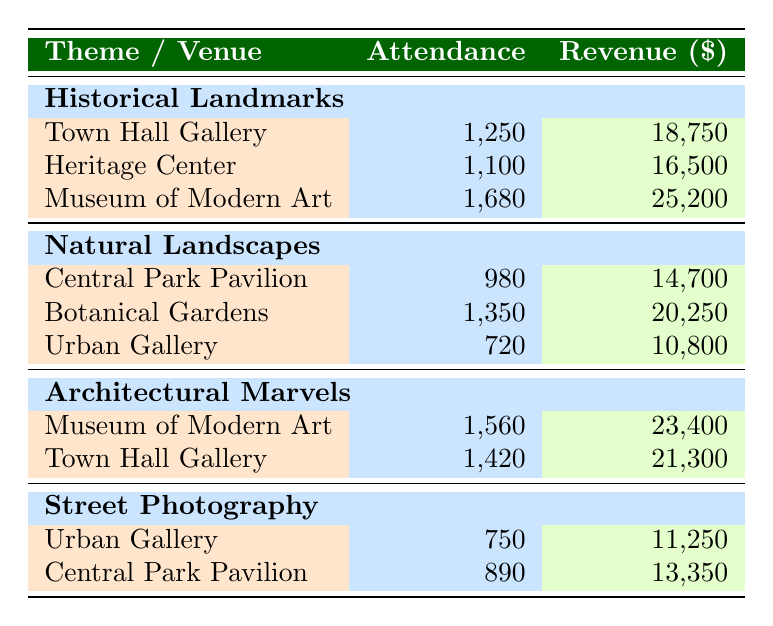What is the total attendance for the "Architectural Marvels" theme? To find the total attendance, I will sum the attendance values for the "Architectural Marvels" theme. The values are 1560 (Museum of Modern Art) and 1420 (Town Hall Gallery). Thus, 1560 + 1420 = 2980.
Answer: 2980 Which venue had the highest revenue and how much was it? Looking at the revenue values, the highest revenue is 25200, which is at the Museum of Modern Art for the "Historical Landmarks" theme.
Answer: Museum of Modern Art, 25200 How many attendees did the "Street Photography" exhibitions have in total? I will sum the attendance from both "Street Photography" entries: 750 (Urban Gallery) and 890 (Central Park Pavilion). So, 750 + 890 = 1640.
Answer: 1640 Did the "Natural Landscapes" theme have an exhibition at the Museum of Modern Art? Reviewing the table, there is no entry for "Natural Landscapes" at the Museum of Modern Art. The entries listed for this theme are at Central Park Pavilion, Botanical Gardens, and Urban Gallery.
Answer: No What is the average revenue for the "Historical Landmarks" theme? To calculate the average revenue, I will first sum the revenue values: 18750 (Town Hall Gallery), 16500 (Heritage Center), and 25200 (Museum of Modern Art), resulting in 18750 + 16500 + 25200 = 60450. Then, I divide this total by the number of exhibitions (3), which gives 60450 / 3 = 20150.
Answer: 20150 Which theme had the least total attendance? To find the least attendance, I will sum attendance from each theme: "Historical Landmarks" (1250 + 1100 + 1680 = 3020), "Natural Landscapes" (980 + 1350 + 720 = 3050), "Architectural Marvels" (1560 + 1420 = 2980), and "Street Photography" (750 + 890 = 1640). The least total attendance is for "Street Photography" with 1640 attendees.
Answer: Street Photography How much revenue was generated by the "Natural Landscapes" exhibitions? I will sum the revenue from the "Natural Landscapes" theme: 14700 (Central Park Pavilion), 20250 (Botanical Gardens), and 10800 (Urban Gallery). Adding these together gives 14700 + 20250 + 10800 = 45750.
Answer: 45750 Were there more attendees at the "Town Hall Gallery" than the "Heritage Center"? Attendance for the Town Hall Gallery is 1250 for "Historical Landmarks," while the Heritage Center has 1100. Since 1250 is greater than 1100, the answer is yes.
Answer: Yes 